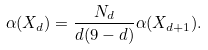Convert formula to latex. <formula><loc_0><loc_0><loc_500><loc_500>\alpha ( X _ { d } ) = \frac { N _ { d } } { d ( 9 - d ) } \alpha ( X _ { d + 1 } ) .</formula> 